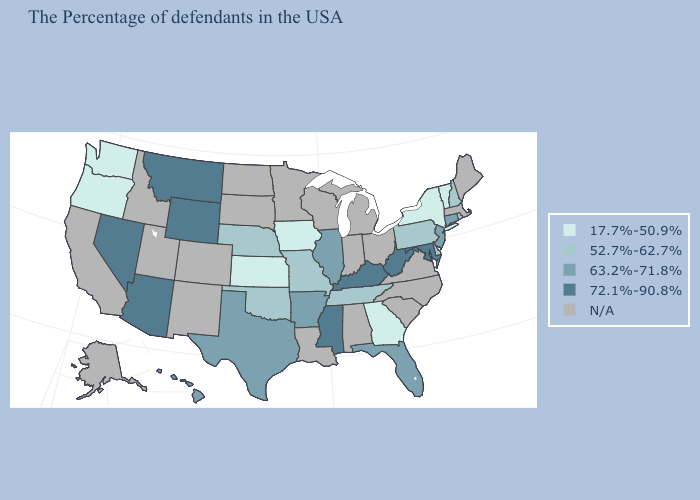Name the states that have a value in the range 52.7%-62.7%?
Short answer required. Rhode Island, New Hampshire, Delaware, Pennsylvania, Tennessee, Missouri, Nebraska, Oklahoma. What is the value of Arizona?
Keep it brief. 72.1%-90.8%. What is the value of Delaware?
Give a very brief answer. 52.7%-62.7%. Name the states that have a value in the range N/A?
Answer briefly. Maine, Massachusetts, Virginia, North Carolina, South Carolina, Ohio, Michigan, Indiana, Alabama, Wisconsin, Louisiana, Minnesota, South Dakota, North Dakota, Colorado, New Mexico, Utah, Idaho, California, Alaska. Name the states that have a value in the range 52.7%-62.7%?
Quick response, please. Rhode Island, New Hampshire, Delaware, Pennsylvania, Tennessee, Missouri, Nebraska, Oklahoma. Name the states that have a value in the range 17.7%-50.9%?
Be succinct. Vermont, New York, Georgia, Iowa, Kansas, Washington, Oregon. What is the lowest value in the South?
Write a very short answer. 17.7%-50.9%. Does Illinois have the highest value in the MidWest?
Keep it brief. Yes. Name the states that have a value in the range 17.7%-50.9%?
Concise answer only. Vermont, New York, Georgia, Iowa, Kansas, Washington, Oregon. Name the states that have a value in the range 63.2%-71.8%?
Keep it brief. Connecticut, New Jersey, Florida, Illinois, Arkansas, Texas, Hawaii. Name the states that have a value in the range 63.2%-71.8%?
Keep it brief. Connecticut, New Jersey, Florida, Illinois, Arkansas, Texas, Hawaii. What is the highest value in the USA?
Give a very brief answer. 72.1%-90.8%. Does Oklahoma have the lowest value in the South?
Answer briefly. No. 